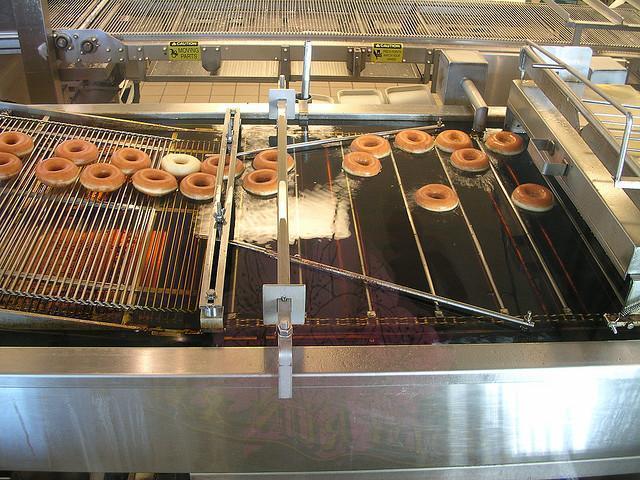What is this type of cooking called?
Pick the right solution, then justify: 'Answer: answer
Rationale: rationale.'
Options: Vegan, handmade, fat-free, production line. Answer: production line.
Rationale: A commercial way of making donuts where they go from one cooking element to the next. 